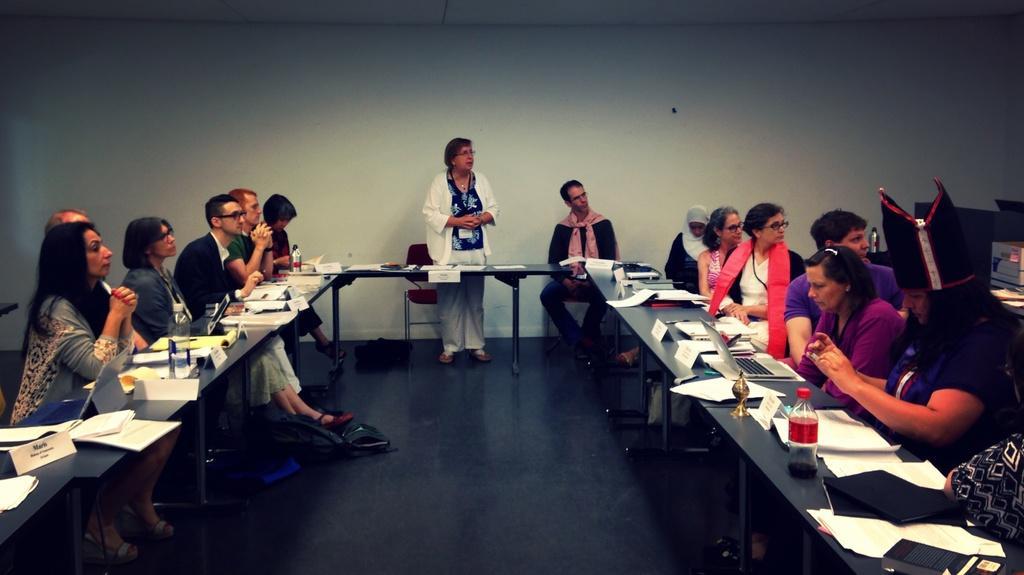Could you give a brief overview of what you see in this image? In this image I can see the group of people sitting in-front of the table. On the table there is a laptop,papers and the bottle. 